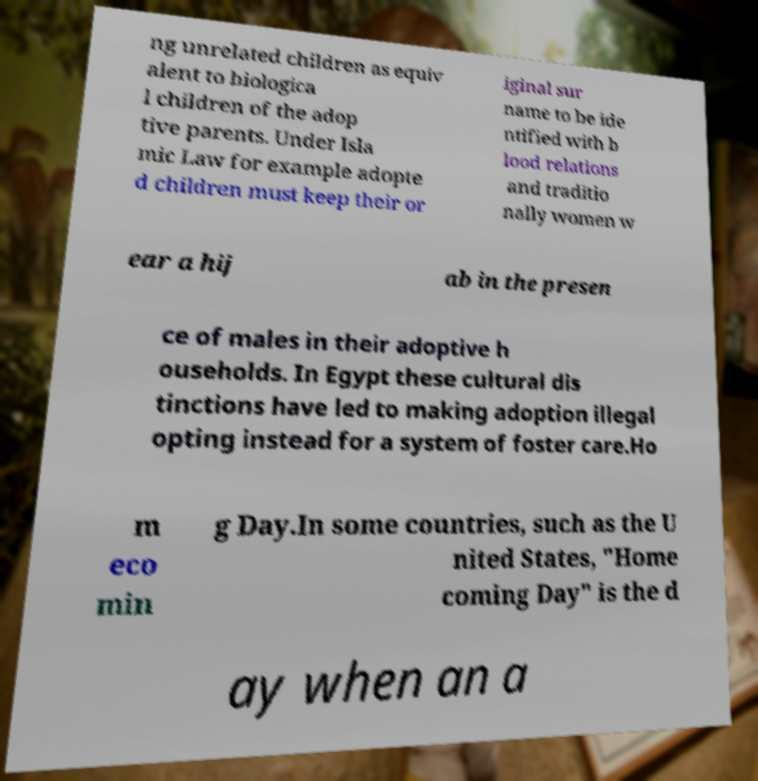Could you extract and type out the text from this image? ng unrelated children as equiv alent to biologica l children of the adop tive parents. Under Isla mic Law for example adopte d children must keep their or iginal sur name to be ide ntified with b lood relations and traditio nally women w ear a hij ab in the presen ce of males in their adoptive h ouseholds. In Egypt these cultural dis tinctions have led to making adoption illegal opting instead for a system of foster care.Ho m eco min g Day.In some countries, such as the U nited States, "Home coming Day" is the d ay when an a 